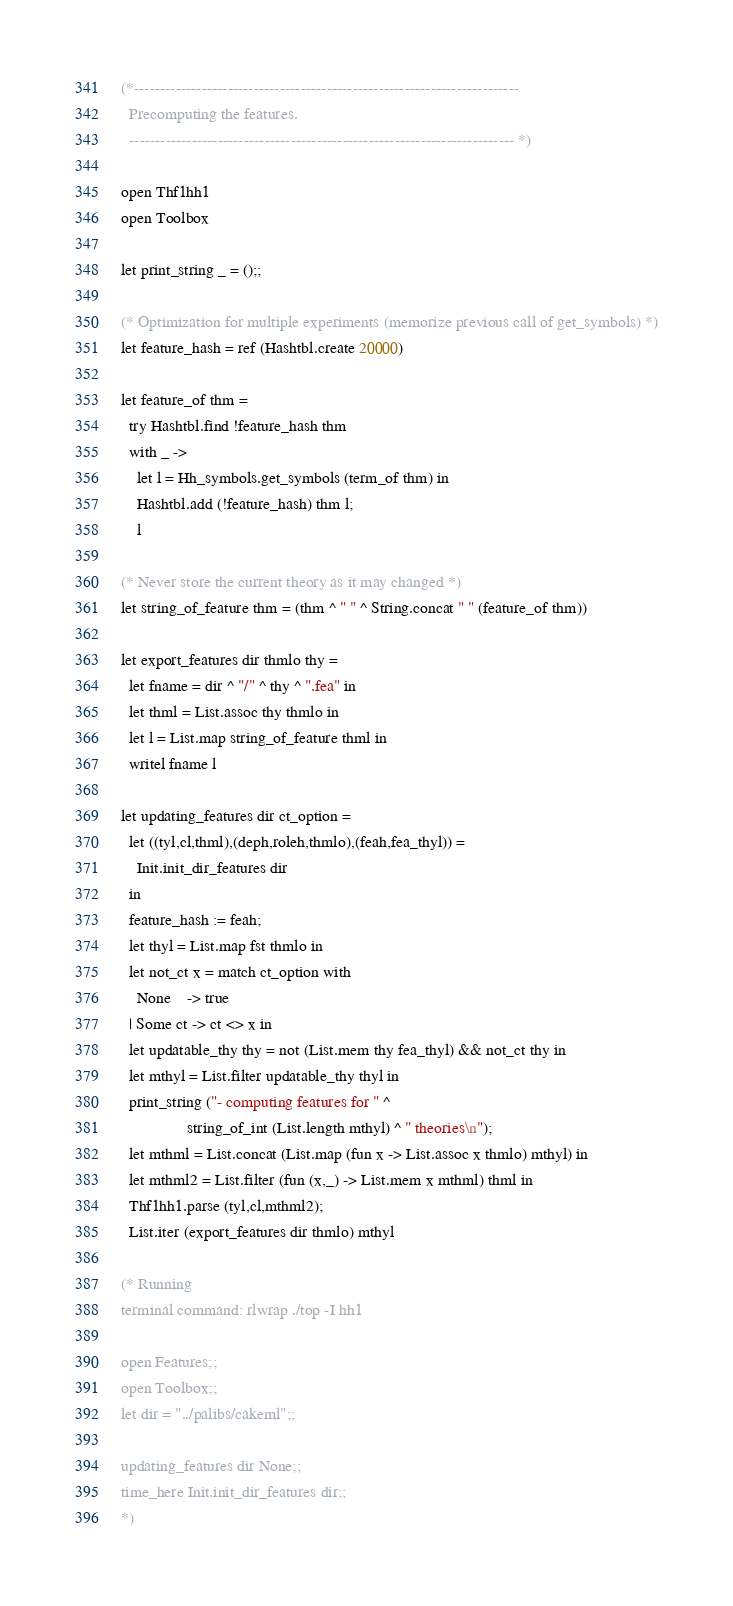<code> <loc_0><loc_0><loc_500><loc_500><_OCaml_>(*-------------------------------------------------------------------------- 
  Precomputing the features.
  -------------------------------------------------------------------------- *)

open Thf1hh1
open Toolbox

let print_string _ = ();;

(* Optimization for multiple experiments (memorize previous call of get_symbols) *)
let feature_hash = ref (Hashtbl.create 20000)

let feature_of thm = 
  try Hashtbl.find !feature_hash thm
  with _ ->
    let l = Hh_symbols.get_symbols (term_of thm) in
    Hashtbl.add (!feature_hash) thm l;
    l

(* Never store the current theory as it may changed *)
let string_of_feature thm = (thm ^ " " ^ String.concat " " (feature_of thm))

let export_features dir thmlo thy = 
  let fname = dir ^ "/" ^ thy ^ ".fea" in
  let thml = List.assoc thy thmlo in
  let l = List.map string_of_feature thml in
  writel fname l

let updating_features dir ct_option =
  let ((tyl,cl,thml),(deph,roleh,thmlo),(feah,fea_thyl)) = 
    Init.init_dir_features dir
  in
  feature_hash := feah;
  let thyl = List.map fst thmlo in
  let not_ct x = match ct_option with
    None    -> true 
  | Some ct -> ct <> x in
  let updatable_thy thy = not (List.mem thy fea_thyl) && not_ct thy in
  let mthyl = List.filter updatable_thy thyl in
  print_string ("- computing features for " ^ 
                string_of_int (List.length mthyl) ^ " theories\n");
  let mthml = List.concat (List.map (fun x -> List.assoc x thmlo) mthyl) in
  let mthml2 = List.filter (fun (x,_) -> List.mem x mthml) thml in
  Thf1hh1.parse (tyl,cl,mthml2);
  List.iter (export_features dir thmlo) mthyl

(* Running
terminal command: rlwrap ./top -I hh1

open Features;;
open Toolbox;;
let dir = "../palibs/cakeml";;

updating_features dir None;;
time_here Init.init_dir_features dir;;
*)
</code> 